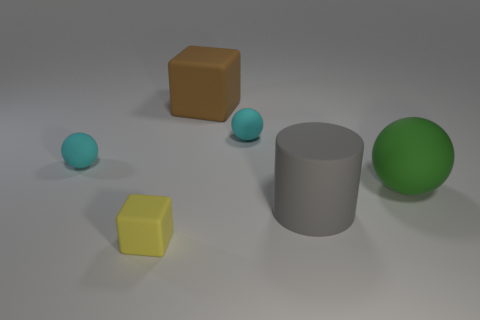Is there a tiny rubber sphere?
Offer a very short reply. Yes. There is a brown thing that is left of the gray thing; does it have the same size as the large green rubber ball?
Give a very brief answer. Yes. Are there fewer gray matte spheres than big green matte objects?
Keep it short and to the point. Yes. What shape is the cyan matte object in front of the tiny ball that is behind the cyan thing that is on the left side of the large brown matte object?
Provide a succinct answer. Sphere. Are there any big gray things made of the same material as the large sphere?
Provide a short and direct response. Yes. Is the color of the sphere that is on the left side of the brown object the same as the small object right of the large brown rubber object?
Provide a short and direct response. Yes. Is the number of large spheres in front of the green matte sphere less than the number of small cubes?
Offer a very short reply. Yes. How many things are either blocks or blocks that are behind the green sphere?
Your answer should be very brief. 2. What color is the cylinder that is the same material as the big block?
Give a very brief answer. Gray. What number of things are either big gray matte cylinders or brown metal spheres?
Your response must be concise. 1. 